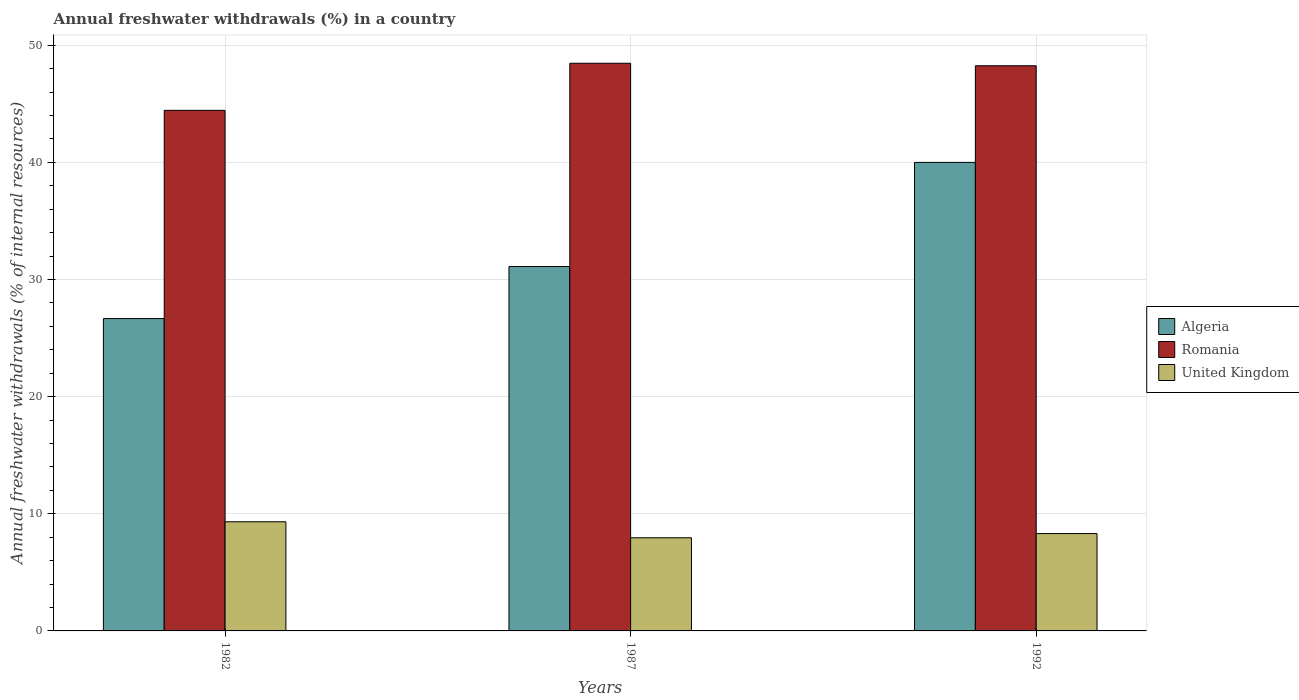Are the number of bars per tick equal to the number of legend labels?
Keep it short and to the point. Yes. Are the number of bars on each tick of the X-axis equal?
Offer a very short reply. Yes. How many bars are there on the 1st tick from the right?
Your response must be concise. 3. What is the percentage of annual freshwater withdrawals in United Kingdom in 1982?
Keep it short and to the point. 9.32. Across all years, what is the maximum percentage of annual freshwater withdrawals in United Kingdom?
Provide a succinct answer. 9.32. Across all years, what is the minimum percentage of annual freshwater withdrawals in United Kingdom?
Ensure brevity in your answer.  7.95. What is the total percentage of annual freshwater withdrawals in Romania in the graph?
Provide a succinct answer. 141.16. What is the difference between the percentage of annual freshwater withdrawals in Algeria in 1987 and that in 1992?
Your response must be concise. -8.89. What is the difference between the percentage of annual freshwater withdrawals in United Kingdom in 1992 and the percentage of annual freshwater withdrawals in Algeria in 1982?
Your response must be concise. -18.36. What is the average percentage of annual freshwater withdrawals in United Kingdom per year?
Ensure brevity in your answer.  8.53. In the year 1987, what is the difference between the percentage of annual freshwater withdrawals in Algeria and percentage of annual freshwater withdrawals in United Kingdom?
Make the answer very short. 23.16. What is the ratio of the percentage of annual freshwater withdrawals in Algeria in 1982 to that in 1987?
Your answer should be compact. 0.86. Is the percentage of annual freshwater withdrawals in Romania in 1987 less than that in 1992?
Offer a very short reply. No. What is the difference between the highest and the second highest percentage of annual freshwater withdrawals in Romania?
Offer a terse response. 0.21. What is the difference between the highest and the lowest percentage of annual freshwater withdrawals in Algeria?
Offer a very short reply. 13.33. What does the 1st bar from the left in 1992 represents?
Give a very brief answer. Algeria. What does the 3rd bar from the right in 1992 represents?
Make the answer very short. Algeria. Is it the case that in every year, the sum of the percentage of annual freshwater withdrawals in Romania and percentage of annual freshwater withdrawals in United Kingdom is greater than the percentage of annual freshwater withdrawals in Algeria?
Your response must be concise. Yes. Are all the bars in the graph horizontal?
Offer a very short reply. No. How many years are there in the graph?
Make the answer very short. 3. Are the values on the major ticks of Y-axis written in scientific E-notation?
Provide a succinct answer. No. Does the graph contain any zero values?
Your response must be concise. No. Where does the legend appear in the graph?
Your answer should be compact. Center right. How are the legend labels stacked?
Provide a succinct answer. Vertical. What is the title of the graph?
Offer a very short reply. Annual freshwater withdrawals (%) in a country. Does "Estonia" appear as one of the legend labels in the graph?
Provide a succinct answer. No. What is the label or title of the X-axis?
Your answer should be very brief. Years. What is the label or title of the Y-axis?
Provide a succinct answer. Annual freshwater withdrawals (% of internal resources). What is the Annual freshwater withdrawals (% of internal resources) of Algeria in 1982?
Offer a very short reply. 26.67. What is the Annual freshwater withdrawals (% of internal resources) of Romania in 1982?
Provide a succinct answer. 44.44. What is the Annual freshwater withdrawals (% of internal resources) of United Kingdom in 1982?
Your answer should be compact. 9.32. What is the Annual freshwater withdrawals (% of internal resources) in Algeria in 1987?
Your answer should be very brief. 31.11. What is the Annual freshwater withdrawals (% of internal resources) of Romania in 1987?
Offer a terse response. 48.46. What is the Annual freshwater withdrawals (% of internal resources) in United Kingdom in 1987?
Give a very brief answer. 7.95. What is the Annual freshwater withdrawals (% of internal resources) of Algeria in 1992?
Give a very brief answer. 40. What is the Annual freshwater withdrawals (% of internal resources) of Romania in 1992?
Keep it short and to the point. 48.25. What is the Annual freshwater withdrawals (% of internal resources) in United Kingdom in 1992?
Ensure brevity in your answer.  8.31. Across all years, what is the maximum Annual freshwater withdrawals (% of internal resources) in Algeria?
Provide a succinct answer. 40. Across all years, what is the maximum Annual freshwater withdrawals (% of internal resources) in Romania?
Provide a succinct answer. 48.46. Across all years, what is the maximum Annual freshwater withdrawals (% of internal resources) in United Kingdom?
Ensure brevity in your answer.  9.32. Across all years, what is the minimum Annual freshwater withdrawals (% of internal resources) of Algeria?
Provide a short and direct response. 26.67. Across all years, what is the minimum Annual freshwater withdrawals (% of internal resources) of Romania?
Your response must be concise. 44.44. Across all years, what is the minimum Annual freshwater withdrawals (% of internal resources) in United Kingdom?
Keep it short and to the point. 7.95. What is the total Annual freshwater withdrawals (% of internal resources) of Algeria in the graph?
Your answer should be compact. 97.78. What is the total Annual freshwater withdrawals (% of internal resources) of Romania in the graph?
Provide a short and direct response. 141.16. What is the total Annual freshwater withdrawals (% of internal resources) in United Kingdom in the graph?
Ensure brevity in your answer.  25.58. What is the difference between the Annual freshwater withdrawals (% of internal resources) of Algeria in 1982 and that in 1987?
Give a very brief answer. -4.44. What is the difference between the Annual freshwater withdrawals (% of internal resources) in Romania in 1982 and that in 1987?
Ensure brevity in your answer.  -4.02. What is the difference between the Annual freshwater withdrawals (% of internal resources) in United Kingdom in 1982 and that in 1987?
Your response must be concise. 1.37. What is the difference between the Annual freshwater withdrawals (% of internal resources) in Algeria in 1982 and that in 1992?
Your answer should be very brief. -13.33. What is the difference between the Annual freshwater withdrawals (% of internal resources) in Romania in 1982 and that in 1992?
Your response must be concise. -3.81. What is the difference between the Annual freshwater withdrawals (% of internal resources) of Algeria in 1987 and that in 1992?
Offer a terse response. -8.89. What is the difference between the Annual freshwater withdrawals (% of internal resources) in Romania in 1987 and that in 1992?
Your answer should be compact. 0.21. What is the difference between the Annual freshwater withdrawals (% of internal resources) of United Kingdom in 1987 and that in 1992?
Provide a short and direct response. -0.36. What is the difference between the Annual freshwater withdrawals (% of internal resources) in Algeria in 1982 and the Annual freshwater withdrawals (% of internal resources) in Romania in 1987?
Ensure brevity in your answer.  -21.8. What is the difference between the Annual freshwater withdrawals (% of internal resources) of Algeria in 1982 and the Annual freshwater withdrawals (% of internal resources) of United Kingdom in 1987?
Your answer should be very brief. 18.71. What is the difference between the Annual freshwater withdrawals (% of internal resources) of Romania in 1982 and the Annual freshwater withdrawals (% of internal resources) of United Kingdom in 1987?
Your answer should be very brief. 36.49. What is the difference between the Annual freshwater withdrawals (% of internal resources) in Algeria in 1982 and the Annual freshwater withdrawals (% of internal resources) in Romania in 1992?
Provide a short and direct response. -21.58. What is the difference between the Annual freshwater withdrawals (% of internal resources) in Algeria in 1982 and the Annual freshwater withdrawals (% of internal resources) in United Kingdom in 1992?
Provide a succinct answer. 18.36. What is the difference between the Annual freshwater withdrawals (% of internal resources) in Romania in 1982 and the Annual freshwater withdrawals (% of internal resources) in United Kingdom in 1992?
Make the answer very short. 36.13. What is the difference between the Annual freshwater withdrawals (% of internal resources) of Algeria in 1987 and the Annual freshwater withdrawals (% of internal resources) of Romania in 1992?
Offer a terse response. -17.14. What is the difference between the Annual freshwater withdrawals (% of internal resources) of Algeria in 1987 and the Annual freshwater withdrawals (% of internal resources) of United Kingdom in 1992?
Offer a terse response. 22.8. What is the difference between the Annual freshwater withdrawals (% of internal resources) in Romania in 1987 and the Annual freshwater withdrawals (% of internal resources) in United Kingdom in 1992?
Keep it short and to the point. 40.15. What is the average Annual freshwater withdrawals (% of internal resources) in Algeria per year?
Provide a succinct answer. 32.59. What is the average Annual freshwater withdrawals (% of internal resources) of Romania per year?
Make the answer very short. 47.05. What is the average Annual freshwater withdrawals (% of internal resources) of United Kingdom per year?
Offer a terse response. 8.53. In the year 1982, what is the difference between the Annual freshwater withdrawals (% of internal resources) in Algeria and Annual freshwater withdrawals (% of internal resources) in Romania?
Your answer should be compact. -17.78. In the year 1982, what is the difference between the Annual freshwater withdrawals (% of internal resources) of Algeria and Annual freshwater withdrawals (% of internal resources) of United Kingdom?
Provide a succinct answer. 17.35. In the year 1982, what is the difference between the Annual freshwater withdrawals (% of internal resources) of Romania and Annual freshwater withdrawals (% of internal resources) of United Kingdom?
Provide a succinct answer. 35.13. In the year 1987, what is the difference between the Annual freshwater withdrawals (% of internal resources) of Algeria and Annual freshwater withdrawals (% of internal resources) of Romania?
Provide a succinct answer. -17.35. In the year 1987, what is the difference between the Annual freshwater withdrawals (% of internal resources) in Algeria and Annual freshwater withdrawals (% of internal resources) in United Kingdom?
Ensure brevity in your answer.  23.16. In the year 1987, what is the difference between the Annual freshwater withdrawals (% of internal resources) of Romania and Annual freshwater withdrawals (% of internal resources) of United Kingdom?
Offer a very short reply. 40.51. In the year 1992, what is the difference between the Annual freshwater withdrawals (% of internal resources) of Algeria and Annual freshwater withdrawals (% of internal resources) of Romania?
Offer a terse response. -8.25. In the year 1992, what is the difference between the Annual freshwater withdrawals (% of internal resources) in Algeria and Annual freshwater withdrawals (% of internal resources) in United Kingdom?
Offer a very short reply. 31.69. In the year 1992, what is the difference between the Annual freshwater withdrawals (% of internal resources) of Romania and Annual freshwater withdrawals (% of internal resources) of United Kingdom?
Offer a terse response. 39.94. What is the ratio of the Annual freshwater withdrawals (% of internal resources) of Algeria in 1982 to that in 1987?
Your answer should be very brief. 0.86. What is the ratio of the Annual freshwater withdrawals (% of internal resources) in Romania in 1982 to that in 1987?
Provide a succinct answer. 0.92. What is the ratio of the Annual freshwater withdrawals (% of internal resources) in United Kingdom in 1982 to that in 1987?
Offer a terse response. 1.17. What is the ratio of the Annual freshwater withdrawals (% of internal resources) in Romania in 1982 to that in 1992?
Ensure brevity in your answer.  0.92. What is the ratio of the Annual freshwater withdrawals (% of internal resources) in United Kingdom in 1982 to that in 1992?
Your response must be concise. 1.12. What is the ratio of the Annual freshwater withdrawals (% of internal resources) of United Kingdom in 1987 to that in 1992?
Give a very brief answer. 0.96. What is the difference between the highest and the second highest Annual freshwater withdrawals (% of internal resources) of Algeria?
Keep it short and to the point. 8.89. What is the difference between the highest and the second highest Annual freshwater withdrawals (% of internal resources) in Romania?
Make the answer very short. 0.21. What is the difference between the highest and the lowest Annual freshwater withdrawals (% of internal resources) in Algeria?
Give a very brief answer. 13.33. What is the difference between the highest and the lowest Annual freshwater withdrawals (% of internal resources) in Romania?
Your answer should be very brief. 4.02. What is the difference between the highest and the lowest Annual freshwater withdrawals (% of internal resources) of United Kingdom?
Your answer should be very brief. 1.37. 